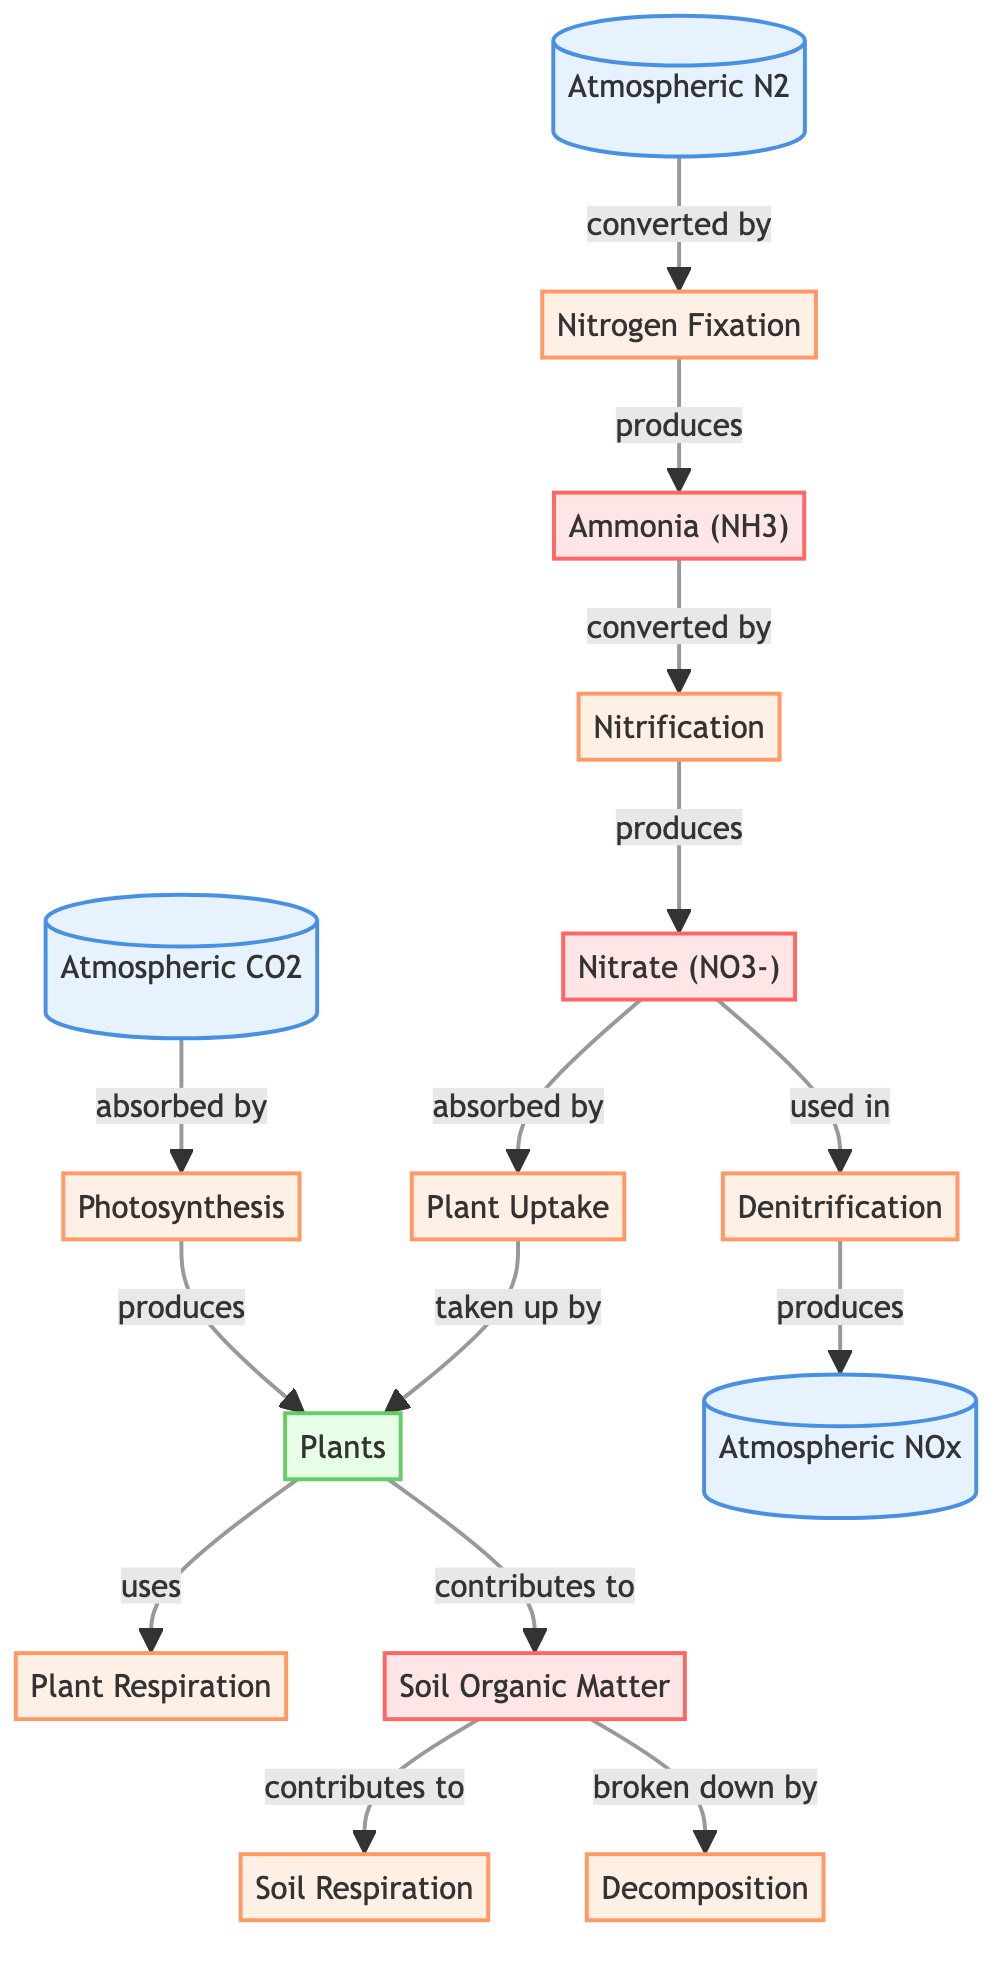What is produced by photosynthesis? In the diagram, photosynthesis is represented as a process that receives carbon dioxide from the atmosphere and produces plants. Thus, the direct output of this process is represented by the node "Plants."
Answer: Plants Which gas is absorbed by nitrogen fixation? The diagram shows that atmospheric nitrogen (N2) is converted by the process of nitrogen fixation. This indicates that nitrogen fixation absorbs N2 from the atmosphere.
Answer: Atmospheric N2 How many processes are involved in the carbon cycle? Reviewing the diagram, we can identify the following processes: Photosynthesis, Plant Respiration, Soil Respiration, Decomposition. Counting these gives a total of four carbon cycle processes.
Answer: 4 What compound is produced during nitrification? Following the diagram’s flow, nitrification converts ammonia (NH3) into nitrate (NO3-). Therefore, the compound produced in this process is nitrate.
Answer: Nitrate (NO3-) Which process is responsible for breaking down soil organic matter? According to the diagram, decomposition is the process that directly breaks down soil organic matter. This establishes the relationship between soil organic matter and the decomposition process.
Answer: Decomposition What is the relationship between plants and soil organic matter? The diagram indicates that plants contribute to soil organic matter. This shows a directional relationship where plants add to the organic component of the soil.
Answer: Contributes to Which gas is a product of denitrification? The diagram illustrates that denitrification process leads to the production of atmospheric NOx. Hence, atmospheric NOx is the product of denitrification.
Answer: Atmospheric NOx How many nodes are related to nitrogen cycling in the diagram? In the diagram, the nitrogen cycling nodes include Atmospheric N2, Nitrogen Fixation, Ammonia (NH3), Nitrification, Nitrate (NO3-), Plant Uptake, Denitrification, and Atmospheric NOx. Counting these gives a total of eight distinct nitrogen-related nodes.
Answer: 8 What is the final output of decomposition in the cycle? The diagram indicates that decomposition leads to soil respiration, which highlights that the end output of decomposition is soil respiration.
Answer: Soil Respiration 